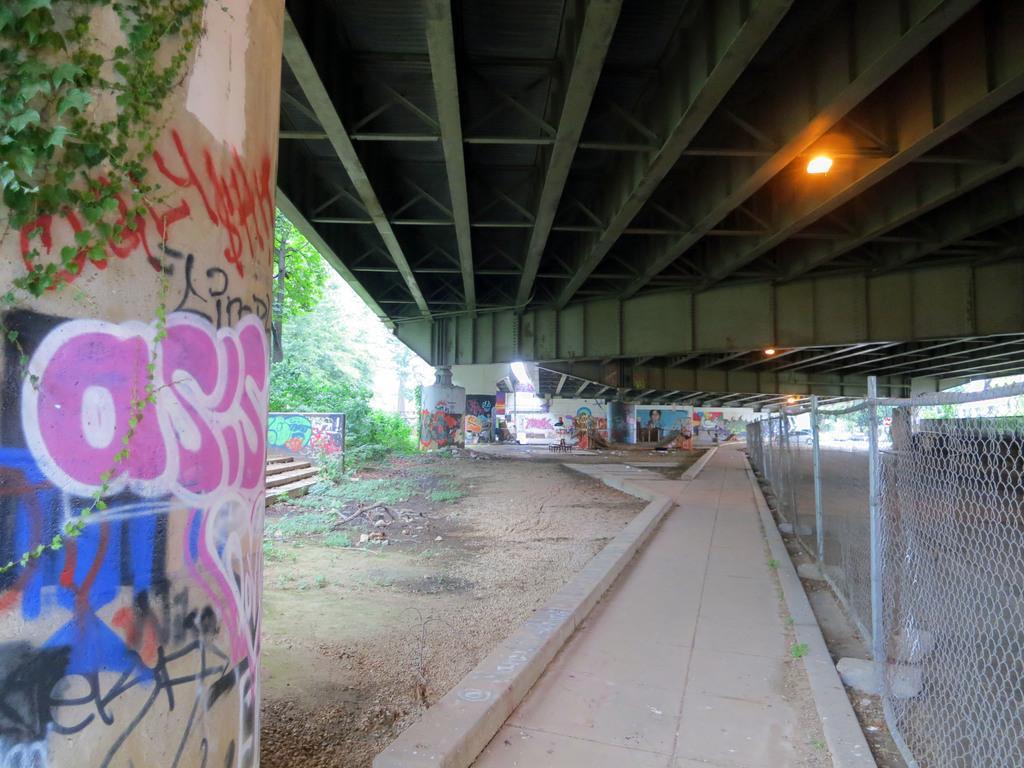Could you give a brief overview of what you see in this image? Graffiti is on the wall. Here we can see trees. Right side of the image there is a light and mesh. 